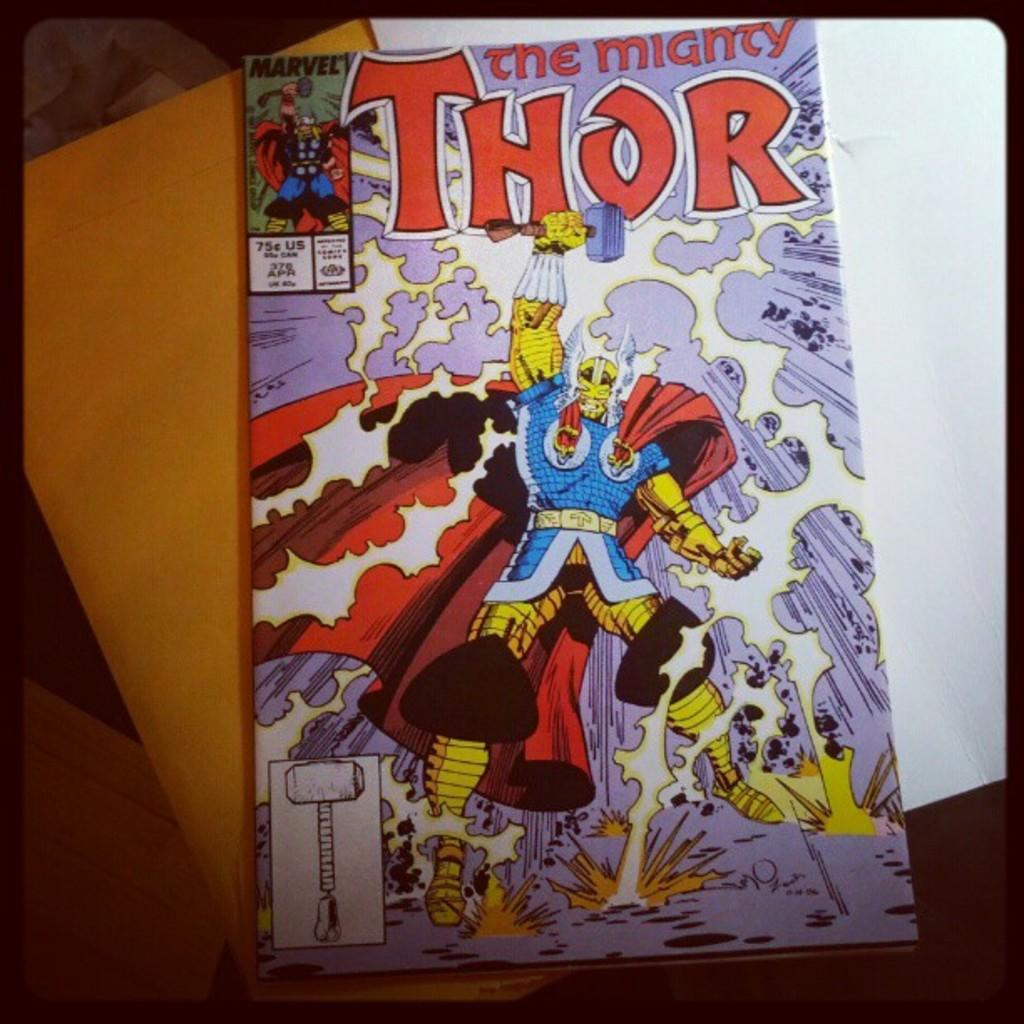<image>
Relay a brief, clear account of the picture shown. The comic book Thor sits on its packaging on a wooden table. 